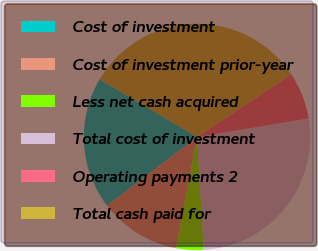Convert chart. <chart><loc_0><loc_0><loc_500><loc_500><pie_chart><fcel>Cost of investment<fcel>Cost of investment prior-year<fcel>Less net cash acquired<fcel>Total cost of investment<fcel>Operating payments 2<fcel>Total cash paid for<nl><fcel>18.87%<fcel>11.69%<fcel>3.91%<fcel>26.66%<fcel>6.73%<fcel>32.14%<nl></chart> 